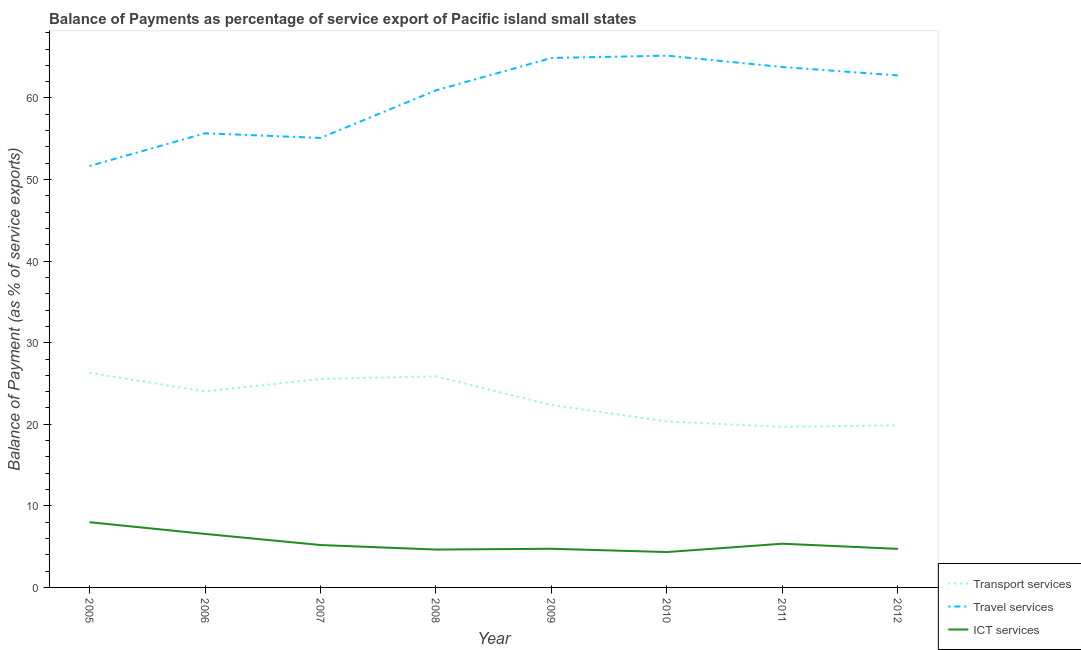How many different coloured lines are there?
Provide a succinct answer. 3. What is the balance of payment of travel services in 2010?
Offer a terse response. 65.19. Across all years, what is the maximum balance of payment of transport services?
Provide a succinct answer. 26.31. Across all years, what is the minimum balance of payment of transport services?
Provide a short and direct response. 19.68. In which year was the balance of payment of ict services maximum?
Offer a very short reply. 2005. What is the total balance of payment of ict services in the graph?
Offer a terse response. 43.55. What is the difference between the balance of payment of travel services in 2007 and that in 2009?
Your response must be concise. -9.8. What is the difference between the balance of payment of ict services in 2007 and the balance of payment of travel services in 2010?
Provide a succinct answer. -59.99. What is the average balance of payment of travel services per year?
Provide a short and direct response. 60. In the year 2008, what is the difference between the balance of payment of transport services and balance of payment of travel services?
Ensure brevity in your answer.  -35.06. In how many years, is the balance of payment of ict services greater than 44 %?
Ensure brevity in your answer.  0. What is the ratio of the balance of payment of travel services in 2009 to that in 2010?
Provide a succinct answer. 1. Is the difference between the balance of payment of transport services in 2007 and 2010 greater than the difference between the balance of payment of travel services in 2007 and 2010?
Offer a terse response. Yes. What is the difference between the highest and the second highest balance of payment of travel services?
Your answer should be very brief. 0.28. What is the difference between the highest and the lowest balance of payment of travel services?
Make the answer very short. 13.53. Is the sum of the balance of payment of ict services in 2005 and 2011 greater than the maximum balance of payment of travel services across all years?
Offer a terse response. No. How many lines are there?
Make the answer very short. 3. What is the difference between two consecutive major ticks on the Y-axis?
Your answer should be very brief. 10. Are the values on the major ticks of Y-axis written in scientific E-notation?
Provide a short and direct response. No. Does the graph contain any zero values?
Keep it short and to the point. No. Does the graph contain grids?
Provide a succinct answer. No. Where does the legend appear in the graph?
Provide a short and direct response. Bottom right. What is the title of the graph?
Make the answer very short. Balance of Payments as percentage of service export of Pacific island small states. Does "Self-employed" appear as one of the legend labels in the graph?
Ensure brevity in your answer.  No. What is the label or title of the Y-axis?
Keep it short and to the point. Balance of Payment (as % of service exports). What is the Balance of Payment (as % of service exports) of Transport services in 2005?
Offer a terse response. 26.31. What is the Balance of Payment (as % of service exports) in Travel services in 2005?
Make the answer very short. 51.66. What is the Balance of Payment (as % of service exports) in ICT services in 2005?
Offer a terse response. 7.99. What is the Balance of Payment (as % of service exports) of Transport services in 2006?
Keep it short and to the point. 24.04. What is the Balance of Payment (as % of service exports) of Travel services in 2006?
Give a very brief answer. 55.67. What is the Balance of Payment (as % of service exports) in ICT services in 2006?
Provide a short and direct response. 6.56. What is the Balance of Payment (as % of service exports) of Transport services in 2007?
Ensure brevity in your answer.  25.56. What is the Balance of Payment (as % of service exports) in Travel services in 2007?
Your answer should be very brief. 55.1. What is the Balance of Payment (as % of service exports) of ICT services in 2007?
Give a very brief answer. 5.2. What is the Balance of Payment (as % of service exports) in Transport services in 2008?
Ensure brevity in your answer.  25.88. What is the Balance of Payment (as % of service exports) of Travel services in 2008?
Your answer should be very brief. 60.94. What is the Balance of Payment (as % of service exports) of ICT services in 2008?
Ensure brevity in your answer.  4.64. What is the Balance of Payment (as % of service exports) in Transport services in 2009?
Make the answer very short. 22.36. What is the Balance of Payment (as % of service exports) in Travel services in 2009?
Your answer should be very brief. 64.91. What is the Balance of Payment (as % of service exports) in ICT services in 2009?
Make the answer very short. 4.74. What is the Balance of Payment (as % of service exports) in Transport services in 2010?
Provide a succinct answer. 20.35. What is the Balance of Payment (as % of service exports) of Travel services in 2010?
Keep it short and to the point. 65.19. What is the Balance of Payment (as % of service exports) of ICT services in 2010?
Your response must be concise. 4.34. What is the Balance of Payment (as % of service exports) of Transport services in 2011?
Your answer should be very brief. 19.68. What is the Balance of Payment (as % of service exports) in Travel services in 2011?
Provide a succinct answer. 63.8. What is the Balance of Payment (as % of service exports) of ICT services in 2011?
Provide a succinct answer. 5.36. What is the Balance of Payment (as % of service exports) in Transport services in 2012?
Your response must be concise. 19.87. What is the Balance of Payment (as % of service exports) in Travel services in 2012?
Your answer should be very brief. 62.76. What is the Balance of Payment (as % of service exports) of ICT services in 2012?
Provide a short and direct response. 4.73. Across all years, what is the maximum Balance of Payment (as % of service exports) of Transport services?
Keep it short and to the point. 26.31. Across all years, what is the maximum Balance of Payment (as % of service exports) in Travel services?
Provide a succinct answer. 65.19. Across all years, what is the maximum Balance of Payment (as % of service exports) in ICT services?
Make the answer very short. 7.99. Across all years, what is the minimum Balance of Payment (as % of service exports) of Transport services?
Provide a short and direct response. 19.68. Across all years, what is the minimum Balance of Payment (as % of service exports) of Travel services?
Ensure brevity in your answer.  51.66. Across all years, what is the minimum Balance of Payment (as % of service exports) in ICT services?
Give a very brief answer. 4.34. What is the total Balance of Payment (as % of service exports) of Transport services in the graph?
Ensure brevity in your answer.  184.03. What is the total Balance of Payment (as % of service exports) of Travel services in the graph?
Offer a very short reply. 480.03. What is the total Balance of Payment (as % of service exports) of ICT services in the graph?
Keep it short and to the point. 43.55. What is the difference between the Balance of Payment (as % of service exports) in Transport services in 2005 and that in 2006?
Give a very brief answer. 2.27. What is the difference between the Balance of Payment (as % of service exports) in Travel services in 2005 and that in 2006?
Provide a succinct answer. -4.01. What is the difference between the Balance of Payment (as % of service exports) of ICT services in 2005 and that in 2006?
Offer a very short reply. 1.43. What is the difference between the Balance of Payment (as % of service exports) in Transport services in 2005 and that in 2007?
Offer a terse response. 0.75. What is the difference between the Balance of Payment (as % of service exports) of Travel services in 2005 and that in 2007?
Provide a succinct answer. -3.44. What is the difference between the Balance of Payment (as % of service exports) of ICT services in 2005 and that in 2007?
Provide a short and direct response. 2.8. What is the difference between the Balance of Payment (as % of service exports) in Transport services in 2005 and that in 2008?
Give a very brief answer. 0.43. What is the difference between the Balance of Payment (as % of service exports) of Travel services in 2005 and that in 2008?
Your answer should be very brief. -9.27. What is the difference between the Balance of Payment (as % of service exports) of ICT services in 2005 and that in 2008?
Provide a short and direct response. 3.35. What is the difference between the Balance of Payment (as % of service exports) in Transport services in 2005 and that in 2009?
Ensure brevity in your answer.  3.95. What is the difference between the Balance of Payment (as % of service exports) in Travel services in 2005 and that in 2009?
Your answer should be compact. -13.24. What is the difference between the Balance of Payment (as % of service exports) of ICT services in 2005 and that in 2009?
Your answer should be very brief. 3.25. What is the difference between the Balance of Payment (as % of service exports) in Transport services in 2005 and that in 2010?
Offer a very short reply. 5.96. What is the difference between the Balance of Payment (as % of service exports) of Travel services in 2005 and that in 2010?
Give a very brief answer. -13.53. What is the difference between the Balance of Payment (as % of service exports) in ICT services in 2005 and that in 2010?
Your answer should be very brief. 3.66. What is the difference between the Balance of Payment (as % of service exports) of Transport services in 2005 and that in 2011?
Provide a short and direct response. 6.63. What is the difference between the Balance of Payment (as % of service exports) of Travel services in 2005 and that in 2011?
Keep it short and to the point. -12.13. What is the difference between the Balance of Payment (as % of service exports) in ICT services in 2005 and that in 2011?
Offer a terse response. 2.64. What is the difference between the Balance of Payment (as % of service exports) in Transport services in 2005 and that in 2012?
Offer a terse response. 6.44. What is the difference between the Balance of Payment (as % of service exports) of Travel services in 2005 and that in 2012?
Provide a succinct answer. -11.1. What is the difference between the Balance of Payment (as % of service exports) in ICT services in 2005 and that in 2012?
Provide a succinct answer. 3.27. What is the difference between the Balance of Payment (as % of service exports) in Transport services in 2006 and that in 2007?
Give a very brief answer. -1.52. What is the difference between the Balance of Payment (as % of service exports) of Travel services in 2006 and that in 2007?
Give a very brief answer. 0.57. What is the difference between the Balance of Payment (as % of service exports) in ICT services in 2006 and that in 2007?
Give a very brief answer. 1.36. What is the difference between the Balance of Payment (as % of service exports) of Transport services in 2006 and that in 2008?
Keep it short and to the point. -1.84. What is the difference between the Balance of Payment (as % of service exports) of Travel services in 2006 and that in 2008?
Your response must be concise. -5.26. What is the difference between the Balance of Payment (as % of service exports) in ICT services in 2006 and that in 2008?
Your answer should be very brief. 1.92. What is the difference between the Balance of Payment (as % of service exports) in Transport services in 2006 and that in 2009?
Give a very brief answer. 1.68. What is the difference between the Balance of Payment (as % of service exports) in Travel services in 2006 and that in 2009?
Keep it short and to the point. -9.23. What is the difference between the Balance of Payment (as % of service exports) in ICT services in 2006 and that in 2009?
Your response must be concise. 1.82. What is the difference between the Balance of Payment (as % of service exports) in Transport services in 2006 and that in 2010?
Give a very brief answer. 3.69. What is the difference between the Balance of Payment (as % of service exports) in Travel services in 2006 and that in 2010?
Ensure brevity in your answer.  -9.52. What is the difference between the Balance of Payment (as % of service exports) in ICT services in 2006 and that in 2010?
Your response must be concise. 2.22. What is the difference between the Balance of Payment (as % of service exports) of Transport services in 2006 and that in 2011?
Provide a succinct answer. 4.36. What is the difference between the Balance of Payment (as % of service exports) of Travel services in 2006 and that in 2011?
Your response must be concise. -8.12. What is the difference between the Balance of Payment (as % of service exports) of ICT services in 2006 and that in 2011?
Provide a succinct answer. 1.2. What is the difference between the Balance of Payment (as % of service exports) of Transport services in 2006 and that in 2012?
Ensure brevity in your answer.  4.17. What is the difference between the Balance of Payment (as % of service exports) of Travel services in 2006 and that in 2012?
Your answer should be compact. -7.09. What is the difference between the Balance of Payment (as % of service exports) of ICT services in 2006 and that in 2012?
Keep it short and to the point. 1.83. What is the difference between the Balance of Payment (as % of service exports) of Transport services in 2007 and that in 2008?
Your answer should be very brief. -0.32. What is the difference between the Balance of Payment (as % of service exports) of Travel services in 2007 and that in 2008?
Offer a terse response. -5.83. What is the difference between the Balance of Payment (as % of service exports) of ICT services in 2007 and that in 2008?
Ensure brevity in your answer.  0.56. What is the difference between the Balance of Payment (as % of service exports) in Transport services in 2007 and that in 2009?
Offer a terse response. 3.2. What is the difference between the Balance of Payment (as % of service exports) of Travel services in 2007 and that in 2009?
Make the answer very short. -9.8. What is the difference between the Balance of Payment (as % of service exports) in ICT services in 2007 and that in 2009?
Offer a terse response. 0.46. What is the difference between the Balance of Payment (as % of service exports) in Transport services in 2007 and that in 2010?
Keep it short and to the point. 5.21. What is the difference between the Balance of Payment (as % of service exports) in Travel services in 2007 and that in 2010?
Your response must be concise. -10.09. What is the difference between the Balance of Payment (as % of service exports) of ICT services in 2007 and that in 2010?
Provide a short and direct response. 0.86. What is the difference between the Balance of Payment (as % of service exports) of Transport services in 2007 and that in 2011?
Provide a succinct answer. 5.88. What is the difference between the Balance of Payment (as % of service exports) in Travel services in 2007 and that in 2011?
Ensure brevity in your answer.  -8.69. What is the difference between the Balance of Payment (as % of service exports) in ICT services in 2007 and that in 2011?
Make the answer very short. -0.16. What is the difference between the Balance of Payment (as % of service exports) in Transport services in 2007 and that in 2012?
Your response must be concise. 5.69. What is the difference between the Balance of Payment (as % of service exports) in Travel services in 2007 and that in 2012?
Keep it short and to the point. -7.66. What is the difference between the Balance of Payment (as % of service exports) of ICT services in 2007 and that in 2012?
Your answer should be very brief. 0.47. What is the difference between the Balance of Payment (as % of service exports) in Transport services in 2008 and that in 2009?
Make the answer very short. 3.52. What is the difference between the Balance of Payment (as % of service exports) in Travel services in 2008 and that in 2009?
Provide a short and direct response. -3.97. What is the difference between the Balance of Payment (as % of service exports) in ICT services in 2008 and that in 2009?
Provide a succinct answer. -0.1. What is the difference between the Balance of Payment (as % of service exports) in Transport services in 2008 and that in 2010?
Keep it short and to the point. 5.53. What is the difference between the Balance of Payment (as % of service exports) in Travel services in 2008 and that in 2010?
Give a very brief answer. -4.25. What is the difference between the Balance of Payment (as % of service exports) of ICT services in 2008 and that in 2010?
Keep it short and to the point. 0.3. What is the difference between the Balance of Payment (as % of service exports) in Transport services in 2008 and that in 2011?
Your answer should be very brief. 6.2. What is the difference between the Balance of Payment (as % of service exports) of Travel services in 2008 and that in 2011?
Make the answer very short. -2.86. What is the difference between the Balance of Payment (as % of service exports) of ICT services in 2008 and that in 2011?
Make the answer very short. -0.72. What is the difference between the Balance of Payment (as % of service exports) of Transport services in 2008 and that in 2012?
Ensure brevity in your answer.  6.01. What is the difference between the Balance of Payment (as % of service exports) of Travel services in 2008 and that in 2012?
Offer a terse response. -1.83. What is the difference between the Balance of Payment (as % of service exports) in ICT services in 2008 and that in 2012?
Your response must be concise. -0.09. What is the difference between the Balance of Payment (as % of service exports) in Transport services in 2009 and that in 2010?
Make the answer very short. 2.01. What is the difference between the Balance of Payment (as % of service exports) in Travel services in 2009 and that in 2010?
Make the answer very short. -0.28. What is the difference between the Balance of Payment (as % of service exports) in ICT services in 2009 and that in 2010?
Offer a terse response. 0.4. What is the difference between the Balance of Payment (as % of service exports) in Transport services in 2009 and that in 2011?
Your response must be concise. 2.68. What is the difference between the Balance of Payment (as % of service exports) in Travel services in 2009 and that in 2011?
Keep it short and to the point. 1.11. What is the difference between the Balance of Payment (as % of service exports) in ICT services in 2009 and that in 2011?
Make the answer very short. -0.62. What is the difference between the Balance of Payment (as % of service exports) of Transport services in 2009 and that in 2012?
Offer a terse response. 2.49. What is the difference between the Balance of Payment (as % of service exports) in Travel services in 2009 and that in 2012?
Keep it short and to the point. 2.14. What is the difference between the Balance of Payment (as % of service exports) of ICT services in 2009 and that in 2012?
Give a very brief answer. 0.01. What is the difference between the Balance of Payment (as % of service exports) in Transport services in 2010 and that in 2011?
Offer a terse response. 0.67. What is the difference between the Balance of Payment (as % of service exports) in Travel services in 2010 and that in 2011?
Offer a very short reply. 1.4. What is the difference between the Balance of Payment (as % of service exports) of ICT services in 2010 and that in 2011?
Offer a very short reply. -1.02. What is the difference between the Balance of Payment (as % of service exports) of Transport services in 2010 and that in 2012?
Ensure brevity in your answer.  0.48. What is the difference between the Balance of Payment (as % of service exports) of Travel services in 2010 and that in 2012?
Make the answer very short. 2.43. What is the difference between the Balance of Payment (as % of service exports) in ICT services in 2010 and that in 2012?
Your answer should be compact. -0.39. What is the difference between the Balance of Payment (as % of service exports) of Transport services in 2011 and that in 2012?
Make the answer very short. -0.19. What is the difference between the Balance of Payment (as % of service exports) in Travel services in 2011 and that in 2012?
Make the answer very short. 1.03. What is the difference between the Balance of Payment (as % of service exports) in ICT services in 2011 and that in 2012?
Give a very brief answer. 0.63. What is the difference between the Balance of Payment (as % of service exports) of Transport services in 2005 and the Balance of Payment (as % of service exports) of Travel services in 2006?
Ensure brevity in your answer.  -29.36. What is the difference between the Balance of Payment (as % of service exports) of Transport services in 2005 and the Balance of Payment (as % of service exports) of ICT services in 2006?
Your response must be concise. 19.75. What is the difference between the Balance of Payment (as % of service exports) in Travel services in 2005 and the Balance of Payment (as % of service exports) in ICT services in 2006?
Offer a terse response. 45.1. What is the difference between the Balance of Payment (as % of service exports) of Transport services in 2005 and the Balance of Payment (as % of service exports) of Travel services in 2007?
Give a very brief answer. -28.8. What is the difference between the Balance of Payment (as % of service exports) of Transport services in 2005 and the Balance of Payment (as % of service exports) of ICT services in 2007?
Provide a short and direct response. 21.11. What is the difference between the Balance of Payment (as % of service exports) in Travel services in 2005 and the Balance of Payment (as % of service exports) in ICT services in 2007?
Ensure brevity in your answer.  46.46. What is the difference between the Balance of Payment (as % of service exports) of Transport services in 2005 and the Balance of Payment (as % of service exports) of Travel services in 2008?
Make the answer very short. -34.63. What is the difference between the Balance of Payment (as % of service exports) in Transport services in 2005 and the Balance of Payment (as % of service exports) in ICT services in 2008?
Offer a very short reply. 21.67. What is the difference between the Balance of Payment (as % of service exports) of Travel services in 2005 and the Balance of Payment (as % of service exports) of ICT services in 2008?
Offer a very short reply. 47.02. What is the difference between the Balance of Payment (as % of service exports) in Transport services in 2005 and the Balance of Payment (as % of service exports) in Travel services in 2009?
Offer a terse response. -38.6. What is the difference between the Balance of Payment (as % of service exports) of Transport services in 2005 and the Balance of Payment (as % of service exports) of ICT services in 2009?
Give a very brief answer. 21.57. What is the difference between the Balance of Payment (as % of service exports) in Travel services in 2005 and the Balance of Payment (as % of service exports) in ICT services in 2009?
Provide a succinct answer. 46.92. What is the difference between the Balance of Payment (as % of service exports) in Transport services in 2005 and the Balance of Payment (as % of service exports) in Travel services in 2010?
Your answer should be compact. -38.88. What is the difference between the Balance of Payment (as % of service exports) of Transport services in 2005 and the Balance of Payment (as % of service exports) of ICT services in 2010?
Keep it short and to the point. 21.97. What is the difference between the Balance of Payment (as % of service exports) in Travel services in 2005 and the Balance of Payment (as % of service exports) in ICT services in 2010?
Ensure brevity in your answer.  47.32. What is the difference between the Balance of Payment (as % of service exports) of Transport services in 2005 and the Balance of Payment (as % of service exports) of Travel services in 2011?
Your response must be concise. -37.49. What is the difference between the Balance of Payment (as % of service exports) in Transport services in 2005 and the Balance of Payment (as % of service exports) in ICT services in 2011?
Give a very brief answer. 20.95. What is the difference between the Balance of Payment (as % of service exports) of Travel services in 2005 and the Balance of Payment (as % of service exports) of ICT services in 2011?
Give a very brief answer. 46.3. What is the difference between the Balance of Payment (as % of service exports) of Transport services in 2005 and the Balance of Payment (as % of service exports) of Travel services in 2012?
Provide a short and direct response. -36.46. What is the difference between the Balance of Payment (as % of service exports) of Transport services in 2005 and the Balance of Payment (as % of service exports) of ICT services in 2012?
Keep it short and to the point. 21.58. What is the difference between the Balance of Payment (as % of service exports) of Travel services in 2005 and the Balance of Payment (as % of service exports) of ICT services in 2012?
Provide a succinct answer. 46.93. What is the difference between the Balance of Payment (as % of service exports) in Transport services in 2006 and the Balance of Payment (as % of service exports) in Travel services in 2007?
Your answer should be very brief. -31.07. What is the difference between the Balance of Payment (as % of service exports) in Transport services in 2006 and the Balance of Payment (as % of service exports) in ICT services in 2007?
Ensure brevity in your answer.  18.84. What is the difference between the Balance of Payment (as % of service exports) of Travel services in 2006 and the Balance of Payment (as % of service exports) of ICT services in 2007?
Your response must be concise. 50.47. What is the difference between the Balance of Payment (as % of service exports) in Transport services in 2006 and the Balance of Payment (as % of service exports) in Travel services in 2008?
Offer a terse response. -36.9. What is the difference between the Balance of Payment (as % of service exports) of Transport services in 2006 and the Balance of Payment (as % of service exports) of ICT services in 2008?
Offer a very short reply. 19.4. What is the difference between the Balance of Payment (as % of service exports) in Travel services in 2006 and the Balance of Payment (as % of service exports) in ICT services in 2008?
Your answer should be very brief. 51.03. What is the difference between the Balance of Payment (as % of service exports) in Transport services in 2006 and the Balance of Payment (as % of service exports) in Travel services in 2009?
Your answer should be compact. -40.87. What is the difference between the Balance of Payment (as % of service exports) in Transport services in 2006 and the Balance of Payment (as % of service exports) in ICT services in 2009?
Your answer should be very brief. 19.3. What is the difference between the Balance of Payment (as % of service exports) in Travel services in 2006 and the Balance of Payment (as % of service exports) in ICT services in 2009?
Your response must be concise. 50.93. What is the difference between the Balance of Payment (as % of service exports) of Transport services in 2006 and the Balance of Payment (as % of service exports) of Travel services in 2010?
Your answer should be compact. -41.15. What is the difference between the Balance of Payment (as % of service exports) in Transport services in 2006 and the Balance of Payment (as % of service exports) in ICT services in 2010?
Your answer should be compact. 19.7. What is the difference between the Balance of Payment (as % of service exports) in Travel services in 2006 and the Balance of Payment (as % of service exports) in ICT services in 2010?
Provide a succinct answer. 51.33. What is the difference between the Balance of Payment (as % of service exports) in Transport services in 2006 and the Balance of Payment (as % of service exports) in Travel services in 2011?
Offer a very short reply. -39.76. What is the difference between the Balance of Payment (as % of service exports) of Transport services in 2006 and the Balance of Payment (as % of service exports) of ICT services in 2011?
Offer a terse response. 18.68. What is the difference between the Balance of Payment (as % of service exports) of Travel services in 2006 and the Balance of Payment (as % of service exports) of ICT services in 2011?
Provide a short and direct response. 50.31. What is the difference between the Balance of Payment (as % of service exports) in Transport services in 2006 and the Balance of Payment (as % of service exports) in Travel services in 2012?
Provide a succinct answer. -38.73. What is the difference between the Balance of Payment (as % of service exports) in Transport services in 2006 and the Balance of Payment (as % of service exports) in ICT services in 2012?
Ensure brevity in your answer.  19.31. What is the difference between the Balance of Payment (as % of service exports) in Travel services in 2006 and the Balance of Payment (as % of service exports) in ICT services in 2012?
Provide a short and direct response. 50.95. What is the difference between the Balance of Payment (as % of service exports) in Transport services in 2007 and the Balance of Payment (as % of service exports) in Travel services in 2008?
Give a very brief answer. -35.38. What is the difference between the Balance of Payment (as % of service exports) in Transport services in 2007 and the Balance of Payment (as % of service exports) in ICT services in 2008?
Your response must be concise. 20.92. What is the difference between the Balance of Payment (as % of service exports) of Travel services in 2007 and the Balance of Payment (as % of service exports) of ICT services in 2008?
Your answer should be very brief. 50.46. What is the difference between the Balance of Payment (as % of service exports) in Transport services in 2007 and the Balance of Payment (as % of service exports) in Travel services in 2009?
Keep it short and to the point. -39.35. What is the difference between the Balance of Payment (as % of service exports) of Transport services in 2007 and the Balance of Payment (as % of service exports) of ICT services in 2009?
Make the answer very short. 20.82. What is the difference between the Balance of Payment (as % of service exports) in Travel services in 2007 and the Balance of Payment (as % of service exports) in ICT services in 2009?
Offer a very short reply. 50.36. What is the difference between the Balance of Payment (as % of service exports) in Transport services in 2007 and the Balance of Payment (as % of service exports) in Travel services in 2010?
Your answer should be compact. -39.63. What is the difference between the Balance of Payment (as % of service exports) in Transport services in 2007 and the Balance of Payment (as % of service exports) in ICT services in 2010?
Provide a short and direct response. 21.22. What is the difference between the Balance of Payment (as % of service exports) of Travel services in 2007 and the Balance of Payment (as % of service exports) of ICT services in 2010?
Keep it short and to the point. 50.77. What is the difference between the Balance of Payment (as % of service exports) of Transport services in 2007 and the Balance of Payment (as % of service exports) of Travel services in 2011?
Give a very brief answer. -38.24. What is the difference between the Balance of Payment (as % of service exports) of Transport services in 2007 and the Balance of Payment (as % of service exports) of ICT services in 2011?
Provide a succinct answer. 20.2. What is the difference between the Balance of Payment (as % of service exports) in Travel services in 2007 and the Balance of Payment (as % of service exports) in ICT services in 2011?
Offer a terse response. 49.75. What is the difference between the Balance of Payment (as % of service exports) in Transport services in 2007 and the Balance of Payment (as % of service exports) in Travel services in 2012?
Your answer should be very brief. -37.21. What is the difference between the Balance of Payment (as % of service exports) in Transport services in 2007 and the Balance of Payment (as % of service exports) in ICT services in 2012?
Your answer should be very brief. 20.83. What is the difference between the Balance of Payment (as % of service exports) of Travel services in 2007 and the Balance of Payment (as % of service exports) of ICT services in 2012?
Provide a succinct answer. 50.38. What is the difference between the Balance of Payment (as % of service exports) of Transport services in 2008 and the Balance of Payment (as % of service exports) of Travel services in 2009?
Give a very brief answer. -39.03. What is the difference between the Balance of Payment (as % of service exports) of Transport services in 2008 and the Balance of Payment (as % of service exports) of ICT services in 2009?
Offer a very short reply. 21.14. What is the difference between the Balance of Payment (as % of service exports) in Travel services in 2008 and the Balance of Payment (as % of service exports) in ICT services in 2009?
Offer a very short reply. 56.2. What is the difference between the Balance of Payment (as % of service exports) in Transport services in 2008 and the Balance of Payment (as % of service exports) in Travel services in 2010?
Offer a very short reply. -39.31. What is the difference between the Balance of Payment (as % of service exports) of Transport services in 2008 and the Balance of Payment (as % of service exports) of ICT services in 2010?
Provide a short and direct response. 21.54. What is the difference between the Balance of Payment (as % of service exports) of Travel services in 2008 and the Balance of Payment (as % of service exports) of ICT services in 2010?
Keep it short and to the point. 56.6. What is the difference between the Balance of Payment (as % of service exports) in Transport services in 2008 and the Balance of Payment (as % of service exports) in Travel services in 2011?
Provide a succinct answer. -37.92. What is the difference between the Balance of Payment (as % of service exports) of Transport services in 2008 and the Balance of Payment (as % of service exports) of ICT services in 2011?
Your response must be concise. 20.52. What is the difference between the Balance of Payment (as % of service exports) of Travel services in 2008 and the Balance of Payment (as % of service exports) of ICT services in 2011?
Give a very brief answer. 55.58. What is the difference between the Balance of Payment (as % of service exports) of Transport services in 2008 and the Balance of Payment (as % of service exports) of Travel services in 2012?
Make the answer very short. -36.89. What is the difference between the Balance of Payment (as % of service exports) in Transport services in 2008 and the Balance of Payment (as % of service exports) in ICT services in 2012?
Offer a very short reply. 21.15. What is the difference between the Balance of Payment (as % of service exports) in Travel services in 2008 and the Balance of Payment (as % of service exports) in ICT services in 2012?
Ensure brevity in your answer.  56.21. What is the difference between the Balance of Payment (as % of service exports) in Transport services in 2009 and the Balance of Payment (as % of service exports) in Travel services in 2010?
Offer a very short reply. -42.83. What is the difference between the Balance of Payment (as % of service exports) in Transport services in 2009 and the Balance of Payment (as % of service exports) in ICT services in 2010?
Give a very brief answer. 18.02. What is the difference between the Balance of Payment (as % of service exports) of Travel services in 2009 and the Balance of Payment (as % of service exports) of ICT services in 2010?
Offer a terse response. 60.57. What is the difference between the Balance of Payment (as % of service exports) of Transport services in 2009 and the Balance of Payment (as % of service exports) of Travel services in 2011?
Your answer should be compact. -41.44. What is the difference between the Balance of Payment (as % of service exports) of Transport services in 2009 and the Balance of Payment (as % of service exports) of ICT services in 2011?
Provide a short and direct response. 17. What is the difference between the Balance of Payment (as % of service exports) of Travel services in 2009 and the Balance of Payment (as % of service exports) of ICT services in 2011?
Your response must be concise. 59.55. What is the difference between the Balance of Payment (as % of service exports) of Transport services in 2009 and the Balance of Payment (as % of service exports) of Travel services in 2012?
Your response must be concise. -40.41. What is the difference between the Balance of Payment (as % of service exports) of Transport services in 2009 and the Balance of Payment (as % of service exports) of ICT services in 2012?
Your answer should be very brief. 17.63. What is the difference between the Balance of Payment (as % of service exports) in Travel services in 2009 and the Balance of Payment (as % of service exports) in ICT services in 2012?
Give a very brief answer. 60.18. What is the difference between the Balance of Payment (as % of service exports) in Transport services in 2010 and the Balance of Payment (as % of service exports) in Travel services in 2011?
Keep it short and to the point. -43.45. What is the difference between the Balance of Payment (as % of service exports) of Transport services in 2010 and the Balance of Payment (as % of service exports) of ICT services in 2011?
Make the answer very short. 14.99. What is the difference between the Balance of Payment (as % of service exports) in Travel services in 2010 and the Balance of Payment (as % of service exports) in ICT services in 2011?
Offer a very short reply. 59.83. What is the difference between the Balance of Payment (as % of service exports) in Transport services in 2010 and the Balance of Payment (as % of service exports) in Travel services in 2012?
Give a very brief answer. -42.42. What is the difference between the Balance of Payment (as % of service exports) of Transport services in 2010 and the Balance of Payment (as % of service exports) of ICT services in 2012?
Keep it short and to the point. 15.62. What is the difference between the Balance of Payment (as % of service exports) of Travel services in 2010 and the Balance of Payment (as % of service exports) of ICT services in 2012?
Keep it short and to the point. 60.46. What is the difference between the Balance of Payment (as % of service exports) of Transport services in 2011 and the Balance of Payment (as % of service exports) of Travel services in 2012?
Your answer should be compact. -43.08. What is the difference between the Balance of Payment (as % of service exports) in Transport services in 2011 and the Balance of Payment (as % of service exports) in ICT services in 2012?
Offer a terse response. 14.95. What is the difference between the Balance of Payment (as % of service exports) of Travel services in 2011 and the Balance of Payment (as % of service exports) of ICT services in 2012?
Provide a short and direct response. 59.07. What is the average Balance of Payment (as % of service exports) of Transport services per year?
Your response must be concise. 23. What is the average Balance of Payment (as % of service exports) of Travel services per year?
Ensure brevity in your answer.  60. What is the average Balance of Payment (as % of service exports) in ICT services per year?
Offer a very short reply. 5.44. In the year 2005, what is the difference between the Balance of Payment (as % of service exports) in Transport services and Balance of Payment (as % of service exports) in Travel services?
Provide a short and direct response. -25.35. In the year 2005, what is the difference between the Balance of Payment (as % of service exports) of Transport services and Balance of Payment (as % of service exports) of ICT services?
Make the answer very short. 18.31. In the year 2005, what is the difference between the Balance of Payment (as % of service exports) of Travel services and Balance of Payment (as % of service exports) of ICT services?
Your answer should be very brief. 43.67. In the year 2006, what is the difference between the Balance of Payment (as % of service exports) in Transport services and Balance of Payment (as % of service exports) in Travel services?
Ensure brevity in your answer.  -31.63. In the year 2006, what is the difference between the Balance of Payment (as % of service exports) in Transport services and Balance of Payment (as % of service exports) in ICT services?
Your answer should be compact. 17.48. In the year 2006, what is the difference between the Balance of Payment (as % of service exports) of Travel services and Balance of Payment (as % of service exports) of ICT services?
Your answer should be compact. 49.11. In the year 2007, what is the difference between the Balance of Payment (as % of service exports) of Transport services and Balance of Payment (as % of service exports) of Travel services?
Make the answer very short. -29.55. In the year 2007, what is the difference between the Balance of Payment (as % of service exports) of Transport services and Balance of Payment (as % of service exports) of ICT services?
Offer a very short reply. 20.36. In the year 2007, what is the difference between the Balance of Payment (as % of service exports) of Travel services and Balance of Payment (as % of service exports) of ICT services?
Keep it short and to the point. 49.91. In the year 2008, what is the difference between the Balance of Payment (as % of service exports) of Transport services and Balance of Payment (as % of service exports) of Travel services?
Give a very brief answer. -35.06. In the year 2008, what is the difference between the Balance of Payment (as % of service exports) in Transport services and Balance of Payment (as % of service exports) in ICT services?
Your answer should be very brief. 21.24. In the year 2008, what is the difference between the Balance of Payment (as % of service exports) in Travel services and Balance of Payment (as % of service exports) in ICT services?
Provide a succinct answer. 56.29. In the year 2009, what is the difference between the Balance of Payment (as % of service exports) of Transport services and Balance of Payment (as % of service exports) of Travel services?
Provide a succinct answer. -42.55. In the year 2009, what is the difference between the Balance of Payment (as % of service exports) in Transport services and Balance of Payment (as % of service exports) in ICT services?
Ensure brevity in your answer.  17.62. In the year 2009, what is the difference between the Balance of Payment (as % of service exports) of Travel services and Balance of Payment (as % of service exports) of ICT services?
Provide a succinct answer. 60.17. In the year 2010, what is the difference between the Balance of Payment (as % of service exports) in Transport services and Balance of Payment (as % of service exports) in Travel services?
Ensure brevity in your answer.  -44.84. In the year 2010, what is the difference between the Balance of Payment (as % of service exports) of Transport services and Balance of Payment (as % of service exports) of ICT services?
Provide a succinct answer. 16.01. In the year 2010, what is the difference between the Balance of Payment (as % of service exports) in Travel services and Balance of Payment (as % of service exports) in ICT services?
Offer a very short reply. 60.85. In the year 2011, what is the difference between the Balance of Payment (as % of service exports) of Transport services and Balance of Payment (as % of service exports) of Travel services?
Offer a terse response. -44.11. In the year 2011, what is the difference between the Balance of Payment (as % of service exports) in Transport services and Balance of Payment (as % of service exports) in ICT services?
Provide a short and direct response. 14.32. In the year 2011, what is the difference between the Balance of Payment (as % of service exports) in Travel services and Balance of Payment (as % of service exports) in ICT services?
Make the answer very short. 58.44. In the year 2012, what is the difference between the Balance of Payment (as % of service exports) in Transport services and Balance of Payment (as % of service exports) in Travel services?
Your answer should be compact. -42.9. In the year 2012, what is the difference between the Balance of Payment (as % of service exports) in Transport services and Balance of Payment (as % of service exports) in ICT services?
Make the answer very short. 15.14. In the year 2012, what is the difference between the Balance of Payment (as % of service exports) of Travel services and Balance of Payment (as % of service exports) of ICT services?
Make the answer very short. 58.04. What is the ratio of the Balance of Payment (as % of service exports) in Transport services in 2005 to that in 2006?
Provide a short and direct response. 1.09. What is the ratio of the Balance of Payment (as % of service exports) in Travel services in 2005 to that in 2006?
Offer a very short reply. 0.93. What is the ratio of the Balance of Payment (as % of service exports) of ICT services in 2005 to that in 2006?
Your answer should be compact. 1.22. What is the ratio of the Balance of Payment (as % of service exports) of Transport services in 2005 to that in 2007?
Offer a very short reply. 1.03. What is the ratio of the Balance of Payment (as % of service exports) in Travel services in 2005 to that in 2007?
Provide a succinct answer. 0.94. What is the ratio of the Balance of Payment (as % of service exports) of ICT services in 2005 to that in 2007?
Your answer should be compact. 1.54. What is the ratio of the Balance of Payment (as % of service exports) in Transport services in 2005 to that in 2008?
Provide a succinct answer. 1.02. What is the ratio of the Balance of Payment (as % of service exports) of Travel services in 2005 to that in 2008?
Keep it short and to the point. 0.85. What is the ratio of the Balance of Payment (as % of service exports) in ICT services in 2005 to that in 2008?
Your response must be concise. 1.72. What is the ratio of the Balance of Payment (as % of service exports) in Transport services in 2005 to that in 2009?
Provide a short and direct response. 1.18. What is the ratio of the Balance of Payment (as % of service exports) in Travel services in 2005 to that in 2009?
Provide a short and direct response. 0.8. What is the ratio of the Balance of Payment (as % of service exports) of ICT services in 2005 to that in 2009?
Your answer should be compact. 1.69. What is the ratio of the Balance of Payment (as % of service exports) in Transport services in 2005 to that in 2010?
Your answer should be compact. 1.29. What is the ratio of the Balance of Payment (as % of service exports) in Travel services in 2005 to that in 2010?
Ensure brevity in your answer.  0.79. What is the ratio of the Balance of Payment (as % of service exports) of ICT services in 2005 to that in 2010?
Provide a short and direct response. 1.84. What is the ratio of the Balance of Payment (as % of service exports) in Transport services in 2005 to that in 2011?
Provide a succinct answer. 1.34. What is the ratio of the Balance of Payment (as % of service exports) in Travel services in 2005 to that in 2011?
Give a very brief answer. 0.81. What is the ratio of the Balance of Payment (as % of service exports) in ICT services in 2005 to that in 2011?
Your answer should be compact. 1.49. What is the ratio of the Balance of Payment (as % of service exports) of Transport services in 2005 to that in 2012?
Ensure brevity in your answer.  1.32. What is the ratio of the Balance of Payment (as % of service exports) in Travel services in 2005 to that in 2012?
Keep it short and to the point. 0.82. What is the ratio of the Balance of Payment (as % of service exports) of ICT services in 2005 to that in 2012?
Your answer should be very brief. 1.69. What is the ratio of the Balance of Payment (as % of service exports) in Transport services in 2006 to that in 2007?
Make the answer very short. 0.94. What is the ratio of the Balance of Payment (as % of service exports) in Travel services in 2006 to that in 2007?
Your answer should be very brief. 1.01. What is the ratio of the Balance of Payment (as % of service exports) in ICT services in 2006 to that in 2007?
Keep it short and to the point. 1.26. What is the ratio of the Balance of Payment (as % of service exports) of Transport services in 2006 to that in 2008?
Provide a short and direct response. 0.93. What is the ratio of the Balance of Payment (as % of service exports) in Travel services in 2006 to that in 2008?
Make the answer very short. 0.91. What is the ratio of the Balance of Payment (as % of service exports) in ICT services in 2006 to that in 2008?
Offer a very short reply. 1.41. What is the ratio of the Balance of Payment (as % of service exports) in Transport services in 2006 to that in 2009?
Provide a short and direct response. 1.08. What is the ratio of the Balance of Payment (as % of service exports) in Travel services in 2006 to that in 2009?
Keep it short and to the point. 0.86. What is the ratio of the Balance of Payment (as % of service exports) of ICT services in 2006 to that in 2009?
Your answer should be very brief. 1.38. What is the ratio of the Balance of Payment (as % of service exports) of Transport services in 2006 to that in 2010?
Ensure brevity in your answer.  1.18. What is the ratio of the Balance of Payment (as % of service exports) in Travel services in 2006 to that in 2010?
Make the answer very short. 0.85. What is the ratio of the Balance of Payment (as % of service exports) of ICT services in 2006 to that in 2010?
Make the answer very short. 1.51. What is the ratio of the Balance of Payment (as % of service exports) in Transport services in 2006 to that in 2011?
Provide a short and direct response. 1.22. What is the ratio of the Balance of Payment (as % of service exports) in Travel services in 2006 to that in 2011?
Offer a terse response. 0.87. What is the ratio of the Balance of Payment (as % of service exports) of ICT services in 2006 to that in 2011?
Provide a succinct answer. 1.22. What is the ratio of the Balance of Payment (as % of service exports) in Transport services in 2006 to that in 2012?
Make the answer very short. 1.21. What is the ratio of the Balance of Payment (as % of service exports) of Travel services in 2006 to that in 2012?
Keep it short and to the point. 0.89. What is the ratio of the Balance of Payment (as % of service exports) of ICT services in 2006 to that in 2012?
Your response must be concise. 1.39. What is the ratio of the Balance of Payment (as % of service exports) in Transport services in 2007 to that in 2008?
Make the answer very short. 0.99. What is the ratio of the Balance of Payment (as % of service exports) of Travel services in 2007 to that in 2008?
Offer a very short reply. 0.9. What is the ratio of the Balance of Payment (as % of service exports) of ICT services in 2007 to that in 2008?
Your answer should be very brief. 1.12. What is the ratio of the Balance of Payment (as % of service exports) in Transport services in 2007 to that in 2009?
Your answer should be very brief. 1.14. What is the ratio of the Balance of Payment (as % of service exports) in Travel services in 2007 to that in 2009?
Offer a very short reply. 0.85. What is the ratio of the Balance of Payment (as % of service exports) of ICT services in 2007 to that in 2009?
Provide a succinct answer. 1.1. What is the ratio of the Balance of Payment (as % of service exports) in Transport services in 2007 to that in 2010?
Your answer should be very brief. 1.26. What is the ratio of the Balance of Payment (as % of service exports) in Travel services in 2007 to that in 2010?
Keep it short and to the point. 0.85. What is the ratio of the Balance of Payment (as % of service exports) of ICT services in 2007 to that in 2010?
Make the answer very short. 1.2. What is the ratio of the Balance of Payment (as % of service exports) of Transport services in 2007 to that in 2011?
Ensure brevity in your answer.  1.3. What is the ratio of the Balance of Payment (as % of service exports) in Travel services in 2007 to that in 2011?
Provide a short and direct response. 0.86. What is the ratio of the Balance of Payment (as % of service exports) in ICT services in 2007 to that in 2011?
Keep it short and to the point. 0.97. What is the ratio of the Balance of Payment (as % of service exports) in Transport services in 2007 to that in 2012?
Offer a very short reply. 1.29. What is the ratio of the Balance of Payment (as % of service exports) in Travel services in 2007 to that in 2012?
Ensure brevity in your answer.  0.88. What is the ratio of the Balance of Payment (as % of service exports) of ICT services in 2007 to that in 2012?
Give a very brief answer. 1.1. What is the ratio of the Balance of Payment (as % of service exports) of Transport services in 2008 to that in 2009?
Keep it short and to the point. 1.16. What is the ratio of the Balance of Payment (as % of service exports) of Travel services in 2008 to that in 2009?
Provide a short and direct response. 0.94. What is the ratio of the Balance of Payment (as % of service exports) in ICT services in 2008 to that in 2009?
Provide a succinct answer. 0.98. What is the ratio of the Balance of Payment (as % of service exports) of Transport services in 2008 to that in 2010?
Provide a succinct answer. 1.27. What is the ratio of the Balance of Payment (as % of service exports) in Travel services in 2008 to that in 2010?
Offer a terse response. 0.93. What is the ratio of the Balance of Payment (as % of service exports) in ICT services in 2008 to that in 2010?
Keep it short and to the point. 1.07. What is the ratio of the Balance of Payment (as % of service exports) of Transport services in 2008 to that in 2011?
Keep it short and to the point. 1.31. What is the ratio of the Balance of Payment (as % of service exports) in Travel services in 2008 to that in 2011?
Your answer should be very brief. 0.96. What is the ratio of the Balance of Payment (as % of service exports) of ICT services in 2008 to that in 2011?
Your answer should be very brief. 0.87. What is the ratio of the Balance of Payment (as % of service exports) of Transport services in 2008 to that in 2012?
Offer a terse response. 1.3. What is the ratio of the Balance of Payment (as % of service exports) of Travel services in 2008 to that in 2012?
Ensure brevity in your answer.  0.97. What is the ratio of the Balance of Payment (as % of service exports) of ICT services in 2008 to that in 2012?
Keep it short and to the point. 0.98. What is the ratio of the Balance of Payment (as % of service exports) in Transport services in 2009 to that in 2010?
Make the answer very short. 1.1. What is the ratio of the Balance of Payment (as % of service exports) of ICT services in 2009 to that in 2010?
Your answer should be very brief. 1.09. What is the ratio of the Balance of Payment (as % of service exports) in Transport services in 2009 to that in 2011?
Keep it short and to the point. 1.14. What is the ratio of the Balance of Payment (as % of service exports) of Travel services in 2009 to that in 2011?
Offer a very short reply. 1.02. What is the ratio of the Balance of Payment (as % of service exports) in ICT services in 2009 to that in 2011?
Make the answer very short. 0.88. What is the ratio of the Balance of Payment (as % of service exports) of Transport services in 2009 to that in 2012?
Make the answer very short. 1.13. What is the ratio of the Balance of Payment (as % of service exports) of Travel services in 2009 to that in 2012?
Provide a succinct answer. 1.03. What is the ratio of the Balance of Payment (as % of service exports) of Transport services in 2010 to that in 2011?
Provide a short and direct response. 1.03. What is the ratio of the Balance of Payment (as % of service exports) of Travel services in 2010 to that in 2011?
Provide a short and direct response. 1.02. What is the ratio of the Balance of Payment (as % of service exports) in ICT services in 2010 to that in 2011?
Make the answer very short. 0.81. What is the ratio of the Balance of Payment (as % of service exports) in Transport services in 2010 to that in 2012?
Your response must be concise. 1.02. What is the ratio of the Balance of Payment (as % of service exports) of Travel services in 2010 to that in 2012?
Ensure brevity in your answer.  1.04. What is the ratio of the Balance of Payment (as % of service exports) in ICT services in 2010 to that in 2012?
Your response must be concise. 0.92. What is the ratio of the Balance of Payment (as % of service exports) in Transport services in 2011 to that in 2012?
Your response must be concise. 0.99. What is the ratio of the Balance of Payment (as % of service exports) in Travel services in 2011 to that in 2012?
Provide a short and direct response. 1.02. What is the ratio of the Balance of Payment (as % of service exports) of ICT services in 2011 to that in 2012?
Offer a terse response. 1.13. What is the difference between the highest and the second highest Balance of Payment (as % of service exports) in Transport services?
Offer a terse response. 0.43. What is the difference between the highest and the second highest Balance of Payment (as % of service exports) of Travel services?
Ensure brevity in your answer.  0.28. What is the difference between the highest and the second highest Balance of Payment (as % of service exports) in ICT services?
Offer a terse response. 1.43. What is the difference between the highest and the lowest Balance of Payment (as % of service exports) of Transport services?
Your response must be concise. 6.63. What is the difference between the highest and the lowest Balance of Payment (as % of service exports) of Travel services?
Your answer should be very brief. 13.53. What is the difference between the highest and the lowest Balance of Payment (as % of service exports) of ICT services?
Ensure brevity in your answer.  3.66. 